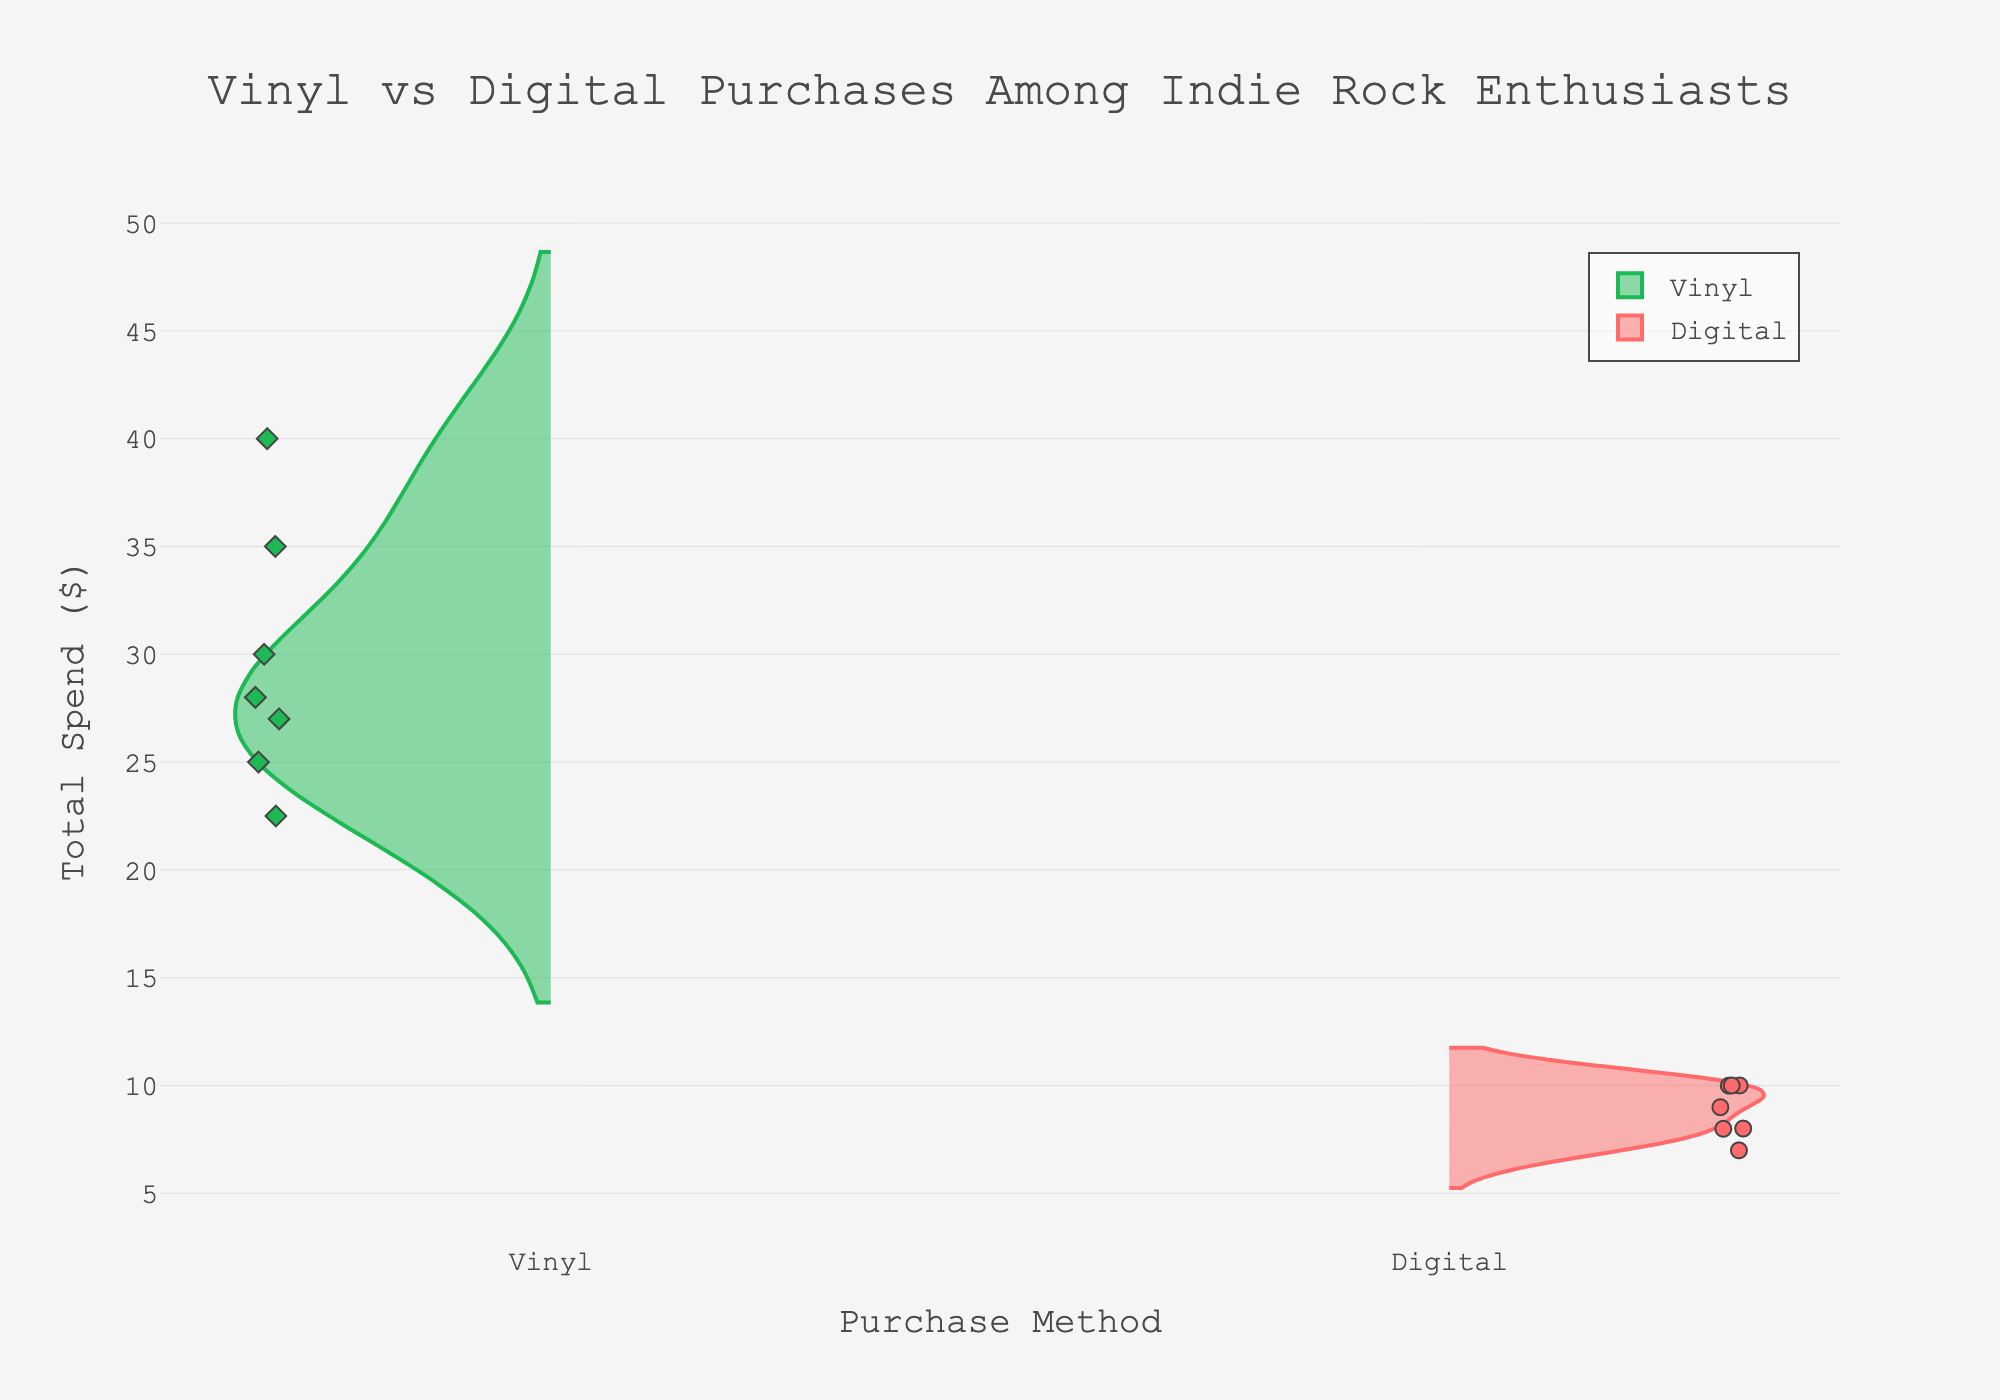Which purchase method has the highest total spend? By observing the violin plots, the Vinyl purchases show data points up to $40, while Digital purchases peak around $10. Therefore, Vinyl has the highest total spend.
Answer: Vinyl What is the title of the chart? The title of the chart is centered at the top and reads "Vinyl vs Digital Purchases Among Indie Rock Enthusiasts".
Answer: Vinyl vs Digital Purchases Among Indie Rock Enthusiasts How many unique data points are displayed for vinyl purchases? By counting the distinct markers (diamonds) on the left side of the violin plot, we see seven unique data points.
Answer: 7 What is the median total spend for digital purchases? The median of the Digital purchases can be approximated by observing the midpoint of the data distribution in the positive violin plot. The values seem to be closely grouped around $8 to $10.
Answer: Around $8-10 Which purchase method has a more diverse spread in terms of total spend? By observing the width and spread of the violin plots, Vinyl has a wider and more varied spread compared to the more narrow and clustered distribution of Digital purchases.
Answer: Vinyl What is the range of total spend for Vinyl purchases? The range is determined by the difference between the highest and lowest data points for Vinyl. From the figure, the Vinyl purchases range from $22.50 to $40.00.
Answer: $22.50 to $40.00 How do Vinyl and Digital purchases compare in terms of frequency per month? This information isn't provided by the violin plots directly. Instead, the plots only indicate the total spend. However, by referring back to the provided data, digital purchases generally show higher frequencies per month.
Answer: Digital has higher frequency per month Which curve has the highest density at a lower total spend? The Digital plot on the positive side shows a higher density of points clustered around the lower total spending range (between $6.99 and $10.00).
Answer: Digital Are the data points more evenly distributed for Vinyl or Digital purchases? By observing the shape of the violin plots, Vinyl purchases appear more evenly spread across a range of values, whereas Digital purchases are more clustered around a specific range.
Answer: Vinyl What is the color used for Digital purchase points? The markers for Digital purchases are circles and are colored a shade of red.
Answer: Red 